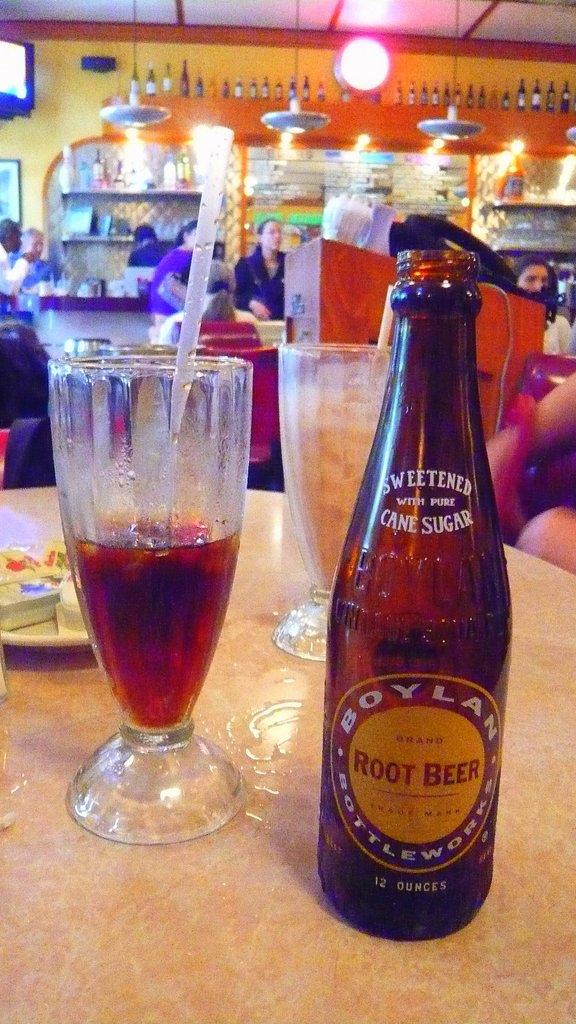What is the name of the drink?
Provide a short and direct response. Root beer. How many ounces is the drink?
Offer a terse response. 12. 